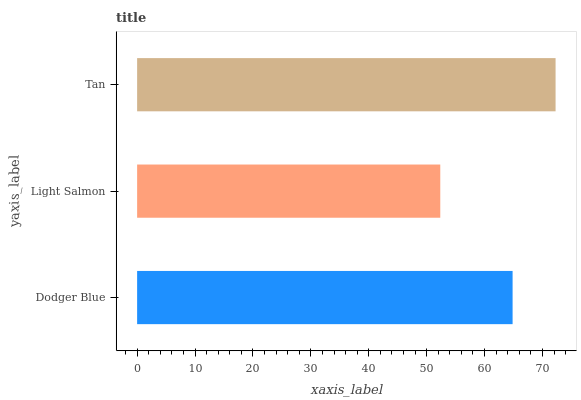Is Light Salmon the minimum?
Answer yes or no. Yes. Is Tan the maximum?
Answer yes or no. Yes. Is Tan the minimum?
Answer yes or no. No. Is Light Salmon the maximum?
Answer yes or no. No. Is Tan greater than Light Salmon?
Answer yes or no. Yes. Is Light Salmon less than Tan?
Answer yes or no. Yes. Is Light Salmon greater than Tan?
Answer yes or no. No. Is Tan less than Light Salmon?
Answer yes or no. No. Is Dodger Blue the high median?
Answer yes or no. Yes. Is Dodger Blue the low median?
Answer yes or no. Yes. Is Tan the high median?
Answer yes or no. No. Is Light Salmon the low median?
Answer yes or no. No. 